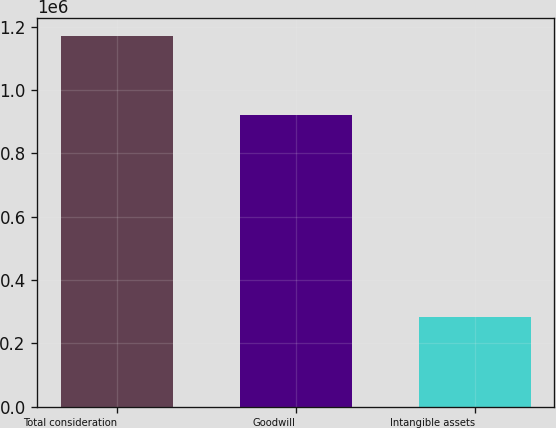Convert chart to OTSL. <chart><loc_0><loc_0><loc_500><loc_500><bar_chart><fcel>Total consideration<fcel>Goodwill<fcel>Intangible assets<nl><fcel>1.17004e+06<fcel>920696<fcel>282144<nl></chart> 